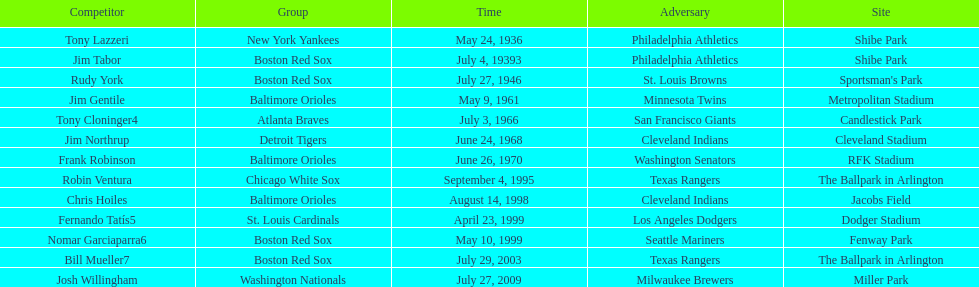What is the count of instances where a boston red sox player has hit two grand slams during one match? 4. 